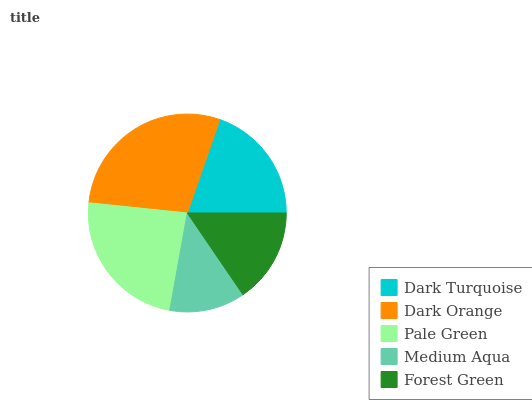Is Medium Aqua the minimum?
Answer yes or no. Yes. Is Dark Orange the maximum?
Answer yes or no. Yes. Is Pale Green the minimum?
Answer yes or no. No. Is Pale Green the maximum?
Answer yes or no. No. Is Dark Orange greater than Pale Green?
Answer yes or no. Yes. Is Pale Green less than Dark Orange?
Answer yes or no. Yes. Is Pale Green greater than Dark Orange?
Answer yes or no. No. Is Dark Orange less than Pale Green?
Answer yes or no. No. Is Dark Turquoise the high median?
Answer yes or no. Yes. Is Dark Turquoise the low median?
Answer yes or no. Yes. Is Dark Orange the high median?
Answer yes or no. No. Is Medium Aqua the low median?
Answer yes or no. No. 